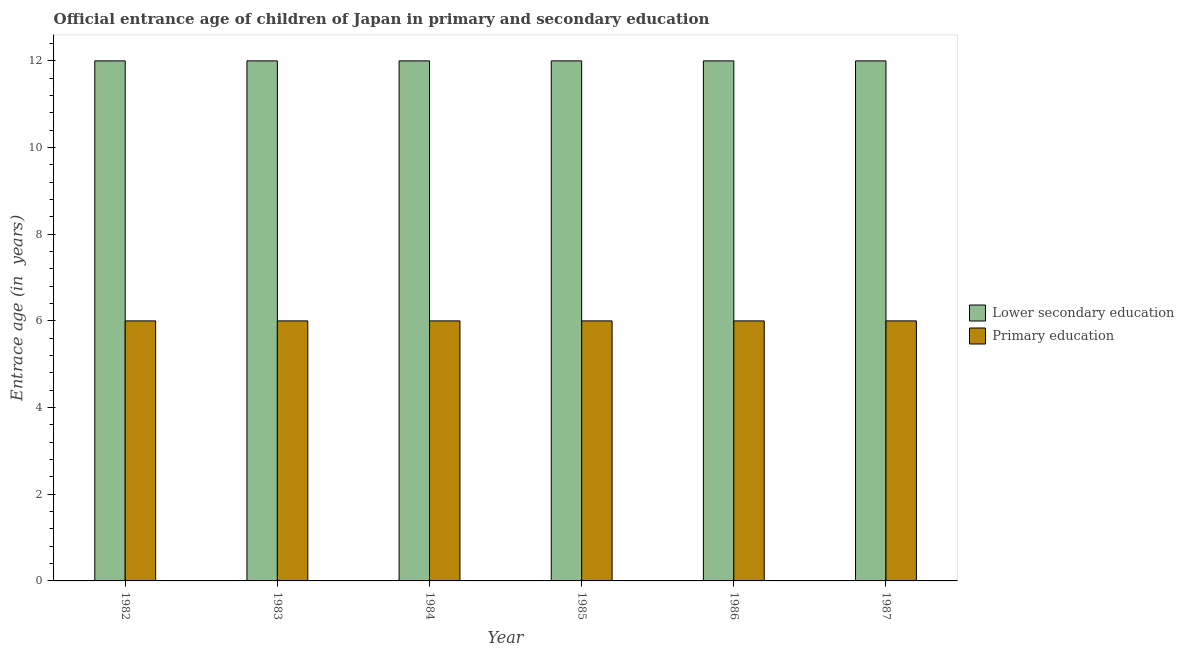How many groups of bars are there?
Your answer should be very brief. 6. What is the label of the 4th group of bars from the left?
Provide a succinct answer. 1985. In how many cases, is the number of bars for a given year not equal to the number of legend labels?
Your answer should be compact. 0. What is the entrance age of children in lower secondary education in 1982?
Provide a succinct answer. 12. Across all years, what is the maximum entrance age of children in lower secondary education?
Offer a very short reply. 12. Across all years, what is the minimum entrance age of children in lower secondary education?
Offer a terse response. 12. In which year was the entrance age of chiildren in primary education maximum?
Ensure brevity in your answer.  1982. In which year was the entrance age of children in lower secondary education minimum?
Your response must be concise. 1982. What is the total entrance age of chiildren in primary education in the graph?
Provide a short and direct response. 36. What is the difference between the entrance age of children in lower secondary education in 1985 and that in 1986?
Keep it short and to the point. 0. What is the difference between the entrance age of children in lower secondary education in 1986 and the entrance age of chiildren in primary education in 1985?
Offer a terse response. 0. What is the average entrance age of chiildren in primary education per year?
Give a very brief answer. 6. In the year 1987, what is the difference between the entrance age of children in lower secondary education and entrance age of chiildren in primary education?
Your answer should be very brief. 0. What is the ratio of the entrance age of children in lower secondary education in 1984 to that in 1986?
Keep it short and to the point. 1. Is the entrance age of chiildren in primary education in 1984 less than that in 1985?
Ensure brevity in your answer.  No. Is the difference between the entrance age of children in lower secondary education in 1984 and 1985 greater than the difference between the entrance age of chiildren in primary education in 1984 and 1985?
Ensure brevity in your answer.  No. What is the difference between the highest and the lowest entrance age of children in lower secondary education?
Provide a succinct answer. 0. In how many years, is the entrance age of children in lower secondary education greater than the average entrance age of children in lower secondary education taken over all years?
Offer a very short reply. 0. Is the sum of the entrance age of chiildren in primary education in 1982 and 1986 greater than the maximum entrance age of children in lower secondary education across all years?
Your response must be concise. Yes. What does the 2nd bar from the left in 1986 represents?
Offer a terse response. Primary education. What does the 2nd bar from the right in 1984 represents?
Ensure brevity in your answer.  Lower secondary education. How many years are there in the graph?
Offer a very short reply. 6. Does the graph contain grids?
Provide a short and direct response. No. How many legend labels are there?
Make the answer very short. 2. What is the title of the graph?
Keep it short and to the point. Official entrance age of children of Japan in primary and secondary education. Does "Secondary Education" appear as one of the legend labels in the graph?
Make the answer very short. No. What is the label or title of the X-axis?
Your response must be concise. Year. What is the label or title of the Y-axis?
Offer a very short reply. Entrace age (in  years). What is the Entrace age (in  years) in Lower secondary education in 1983?
Provide a short and direct response. 12. What is the Entrace age (in  years) in Primary education in 1983?
Provide a succinct answer. 6. What is the Entrace age (in  years) in Lower secondary education in 1984?
Your answer should be very brief. 12. What is the Entrace age (in  years) of Primary education in 1984?
Offer a very short reply. 6. What is the Entrace age (in  years) in Lower secondary education in 1986?
Provide a short and direct response. 12. What is the Entrace age (in  years) in Primary education in 1987?
Ensure brevity in your answer.  6. Across all years, what is the maximum Entrace age (in  years) in Primary education?
Ensure brevity in your answer.  6. Across all years, what is the minimum Entrace age (in  years) in Lower secondary education?
Give a very brief answer. 12. Across all years, what is the minimum Entrace age (in  years) of Primary education?
Your response must be concise. 6. What is the total Entrace age (in  years) of Lower secondary education in the graph?
Offer a very short reply. 72. What is the total Entrace age (in  years) of Primary education in the graph?
Offer a very short reply. 36. What is the difference between the Entrace age (in  years) in Lower secondary education in 1982 and that in 1984?
Provide a short and direct response. 0. What is the difference between the Entrace age (in  years) in Primary education in 1982 and that in 1984?
Your answer should be very brief. 0. What is the difference between the Entrace age (in  years) of Lower secondary education in 1982 and that in 1985?
Provide a short and direct response. 0. What is the difference between the Entrace age (in  years) in Primary education in 1982 and that in 1985?
Your response must be concise. 0. What is the difference between the Entrace age (in  years) of Lower secondary education in 1982 and that in 1986?
Offer a terse response. 0. What is the difference between the Entrace age (in  years) of Primary education in 1982 and that in 1986?
Your answer should be very brief. 0. What is the difference between the Entrace age (in  years) in Lower secondary education in 1982 and that in 1987?
Provide a short and direct response. 0. What is the difference between the Entrace age (in  years) in Primary education in 1983 and that in 1984?
Your answer should be very brief. 0. What is the difference between the Entrace age (in  years) of Lower secondary education in 1983 and that in 1985?
Provide a short and direct response. 0. What is the difference between the Entrace age (in  years) of Primary education in 1983 and that in 1985?
Provide a succinct answer. 0. What is the difference between the Entrace age (in  years) in Lower secondary education in 1983 and that in 1987?
Your answer should be very brief. 0. What is the difference between the Entrace age (in  years) of Primary education in 1983 and that in 1987?
Offer a very short reply. 0. What is the difference between the Entrace age (in  years) of Lower secondary education in 1984 and that in 1985?
Keep it short and to the point. 0. What is the difference between the Entrace age (in  years) in Primary education in 1984 and that in 1985?
Provide a short and direct response. 0. What is the difference between the Entrace age (in  years) of Lower secondary education in 1984 and that in 1986?
Offer a very short reply. 0. What is the difference between the Entrace age (in  years) of Primary education in 1984 and that in 1986?
Ensure brevity in your answer.  0. What is the difference between the Entrace age (in  years) of Lower secondary education in 1984 and that in 1987?
Your response must be concise. 0. What is the difference between the Entrace age (in  years) in Primary education in 1985 and that in 1986?
Ensure brevity in your answer.  0. What is the difference between the Entrace age (in  years) in Lower secondary education in 1985 and that in 1987?
Give a very brief answer. 0. What is the difference between the Entrace age (in  years) in Lower secondary education in 1982 and the Entrace age (in  years) in Primary education in 1983?
Make the answer very short. 6. What is the difference between the Entrace age (in  years) of Lower secondary education in 1982 and the Entrace age (in  years) of Primary education in 1984?
Your answer should be very brief. 6. What is the difference between the Entrace age (in  years) of Lower secondary education in 1982 and the Entrace age (in  years) of Primary education in 1985?
Offer a very short reply. 6. What is the difference between the Entrace age (in  years) of Lower secondary education in 1982 and the Entrace age (in  years) of Primary education in 1986?
Your answer should be very brief. 6. What is the difference between the Entrace age (in  years) in Lower secondary education in 1982 and the Entrace age (in  years) in Primary education in 1987?
Provide a succinct answer. 6. What is the difference between the Entrace age (in  years) in Lower secondary education in 1985 and the Entrace age (in  years) in Primary education in 1986?
Your answer should be very brief. 6. What is the difference between the Entrace age (in  years) in Lower secondary education in 1985 and the Entrace age (in  years) in Primary education in 1987?
Keep it short and to the point. 6. What is the average Entrace age (in  years) in Lower secondary education per year?
Give a very brief answer. 12. What is the average Entrace age (in  years) of Primary education per year?
Provide a succinct answer. 6. In the year 1984, what is the difference between the Entrace age (in  years) of Lower secondary education and Entrace age (in  years) of Primary education?
Your response must be concise. 6. In the year 1985, what is the difference between the Entrace age (in  years) in Lower secondary education and Entrace age (in  years) in Primary education?
Offer a terse response. 6. In the year 1987, what is the difference between the Entrace age (in  years) in Lower secondary education and Entrace age (in  years) in Primary education?
Provide a short and direct response. 6. What is the ratio of the Entrace age (in  years) of Primary education in 1982 to that in 1983?
Your answer should be compact. 1. What is the ratio of the Entrace age (in  years) in Lower secondary education in 1982 to that in 1984?
Provide a succinct answer. 1. What is the ratio of the Entrace age (in  years) in Primary education in 1982 to that in 1984?
Ensure brevity in your answer.  1. What is the ratio of the Entrace age (in  years) of Lower secondary education in 1982 to that in 1985?
Offer a very short reply. 1. What is the ratio of the Entrace age (in  years) in Lower secondary education in 1982 to that in 1987?
Your answer should be very brief. 1. What is the ratio of the Entrace age (in  years) in Primary education in 1982 to that in 1987?
Provide a succinct answer. 1. What is the ratio of the Entrace age (in  years) in Lower secondary education in 1983 to that in 1984?
Make the answer very short. 1. What is the ratio of the Entrace age (in  years) in Primary education in 1983 to that in 1984?
Your answer should be compact. 1. What is the ratio of the Entrace age (in  years) in Lower secondary education in 1983 to that in 1985?
Your answer should be compact. 1. What is the ratio of the Entrace age (in  years) of Primary education in 1983 to that in 1986?
Give a very brief answer. 1. What is the ratio of the Entrace age (in  years) of Primary education in 1984 to that in 1985?
Your answer should be compact. 1. What is the ratio of the Entrace age (in  years) of Lower secondary education in 1984 to that in 1986?
Give a very brief answer. 1. What is the ratio of the Entrace age (in  years) of Primary education in 1985 to that in 1986?
Your response must be concise. 1. What is the ratio of the Entrace age (in  years) in Primary education in 1985 to that in 1987?
Give a very brief answer. 1. What is the difference between the highest and the lowest Entrace age (in  years) of Lower secondary education?
Offer a terse response. 0. 